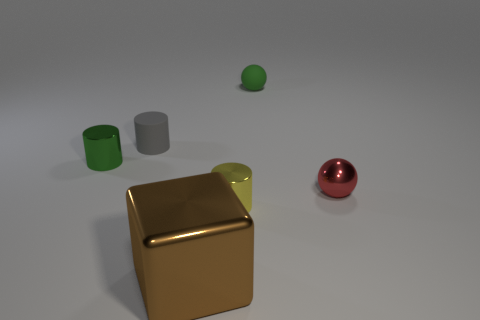What shape is the object that is on the right side of the green thing that is on the right side of the gray object?
Ensure brevity in your answer.  Sphere. How many other things are the same shape as the green rubber object?
Provide a short and direct response. 1. There is a ball behind the tiny green cylinder that is behind the large shiny thing; what size is it?
Provide a short and direct response. Small. Is there a small gray rubber object?
Your answer should be very brief. Yes. There is a yellow cylinder to the right of the cube; what number of things are behind it?
Your answer should be very brief. 4. What shape is the green matte thing that is behind the small red metal object?
Your answer should be compact. Sphere. The sphere behind the tiny cylinder behind the shiny cylinder behind the tiny yellow metallic cylinder is made of what material?
Keep it short and to the point. Rubber. What number of other objects are the same size as the red metal object?
Keep it short and to the point. 4. There is a tiny yellow object that is the same shape as the green metal thing; what is it made of?
Give a very brief answer. Metal. What is the color of the block?
Your response must be concise. Brown. 